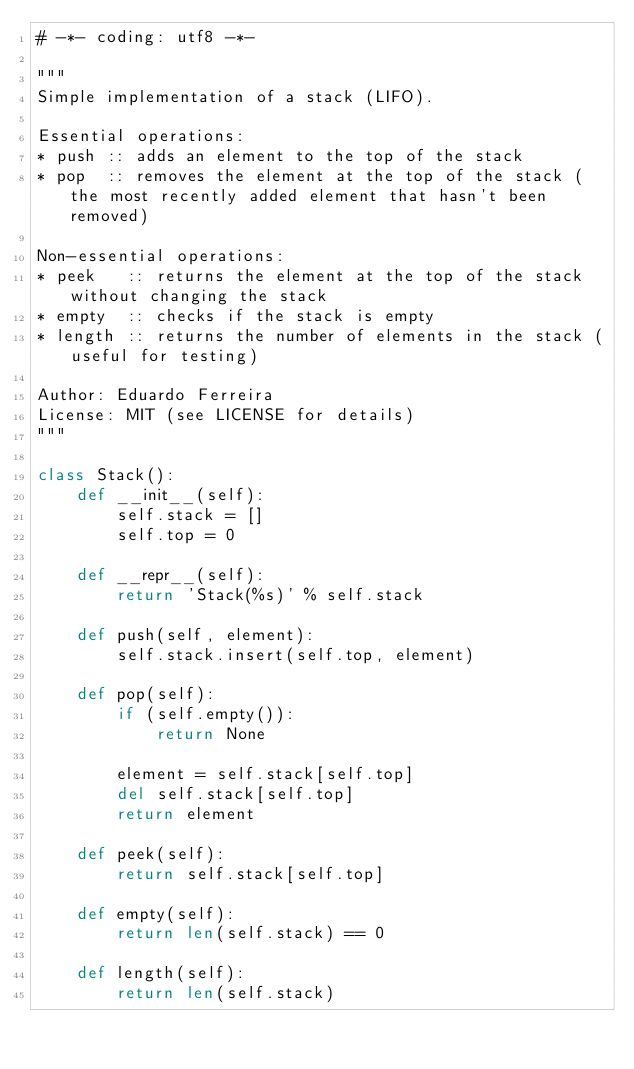Convert code to text. <code><loc_0><loc_0><loc_500><loc_500><_Python_># -*- coding: utf8 -*-

"""
Simple implementation of a stack (LIFO).

Essential operations:
* push :: adds an element to the top of the stack
* pop  :: removes the element at the top of the stack (the most recently added element that hasn't been removed)

Non-essential operations:
* peek   :: returns the element at the top of the stack without changing the stack
* empty  :: checks if the stack is empty
* length :: returns the number of elements in the stack (useful for testing)

Author: Eduardo Ferreira
License: MIT (see LICENSE for details)
"""

class Stack():
    def __init__(self):
        self.stack = []
        self.top = 0

    def __repr__(self):
        return 'Stack(%s)' % self.stack

    def push(self, element):
        self.stack.insert(self.top, element)

    def pop(self):
        if (self.empty()):
            return None

        element = self.stack[self.top]
        del self.stack[self.top]
        return element

    def peek(self):
        return self.stack[self.top]

    def empty(self):
        return len(self.stack) == 0

    def length(self):
        return len(self.stack)
</code> 